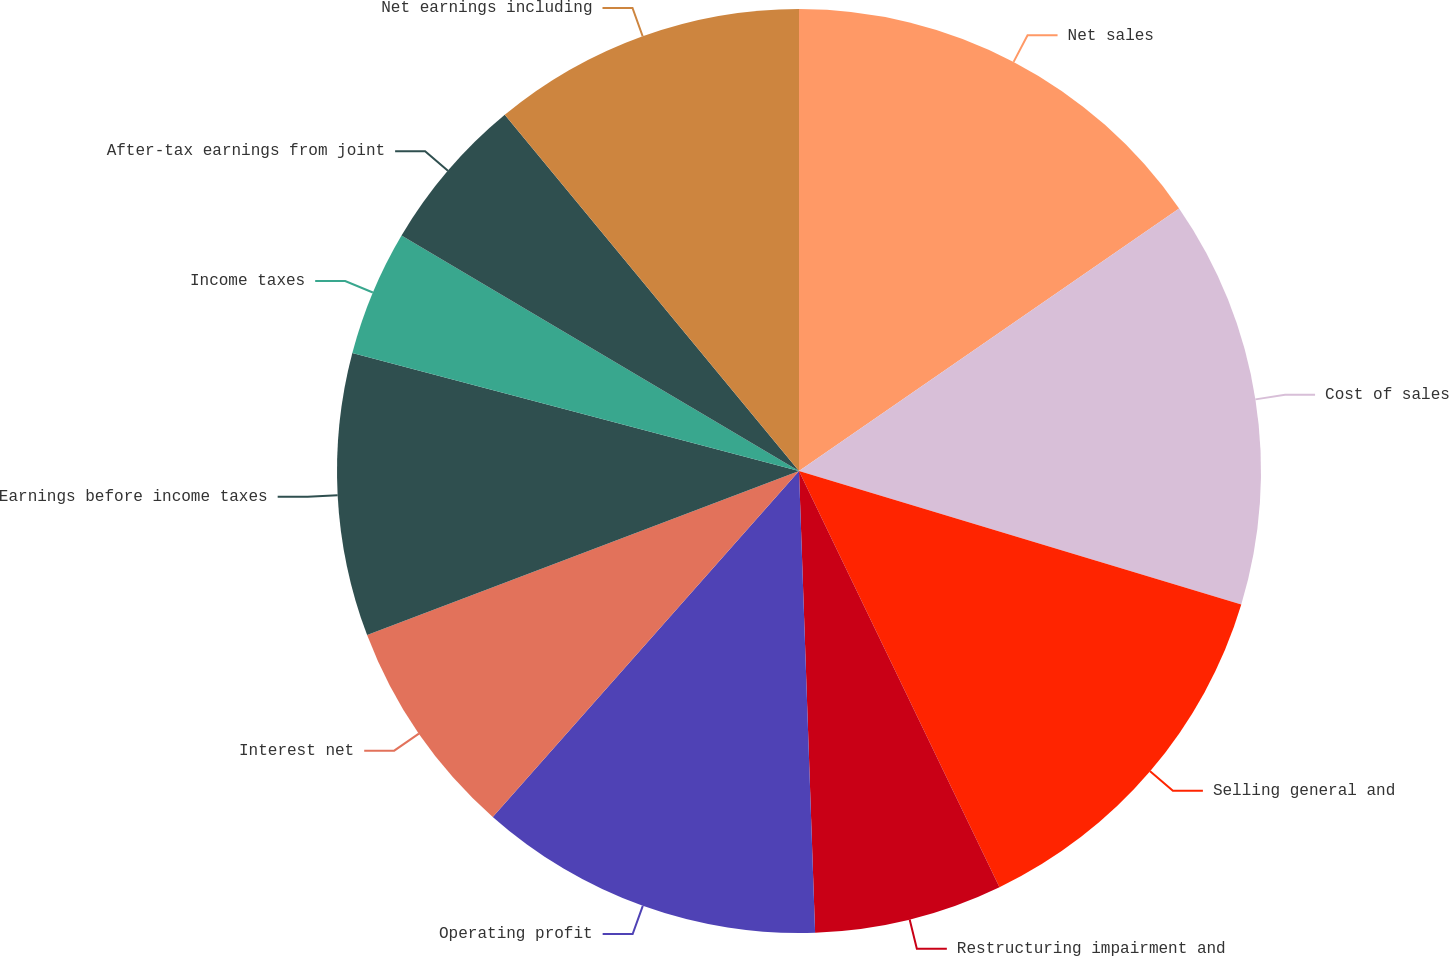Convert chart. <chart><loc_0><loc_0><loc_500><loc_500><pie_chart><fcel>Net sales<fcel>Cost of sales<fcel>Selling general and<fcel>Restructuring impairment and<fcel>Operating profit<fcel>Interest net<fcel>Earnings before income taxes<fcel>Income taxes<fcel>After-tax earnings from joint<fcel>Net earnings including<nl><fcel>15.38%<fcel>14.29%<fcel>13.19%<fcel>6.59%<fcel>12.09%<fcel>7.69%<fcel>9.89%<fcel>4.4%<fcel>5.5%<fcel>10.99%<nl></chart> 